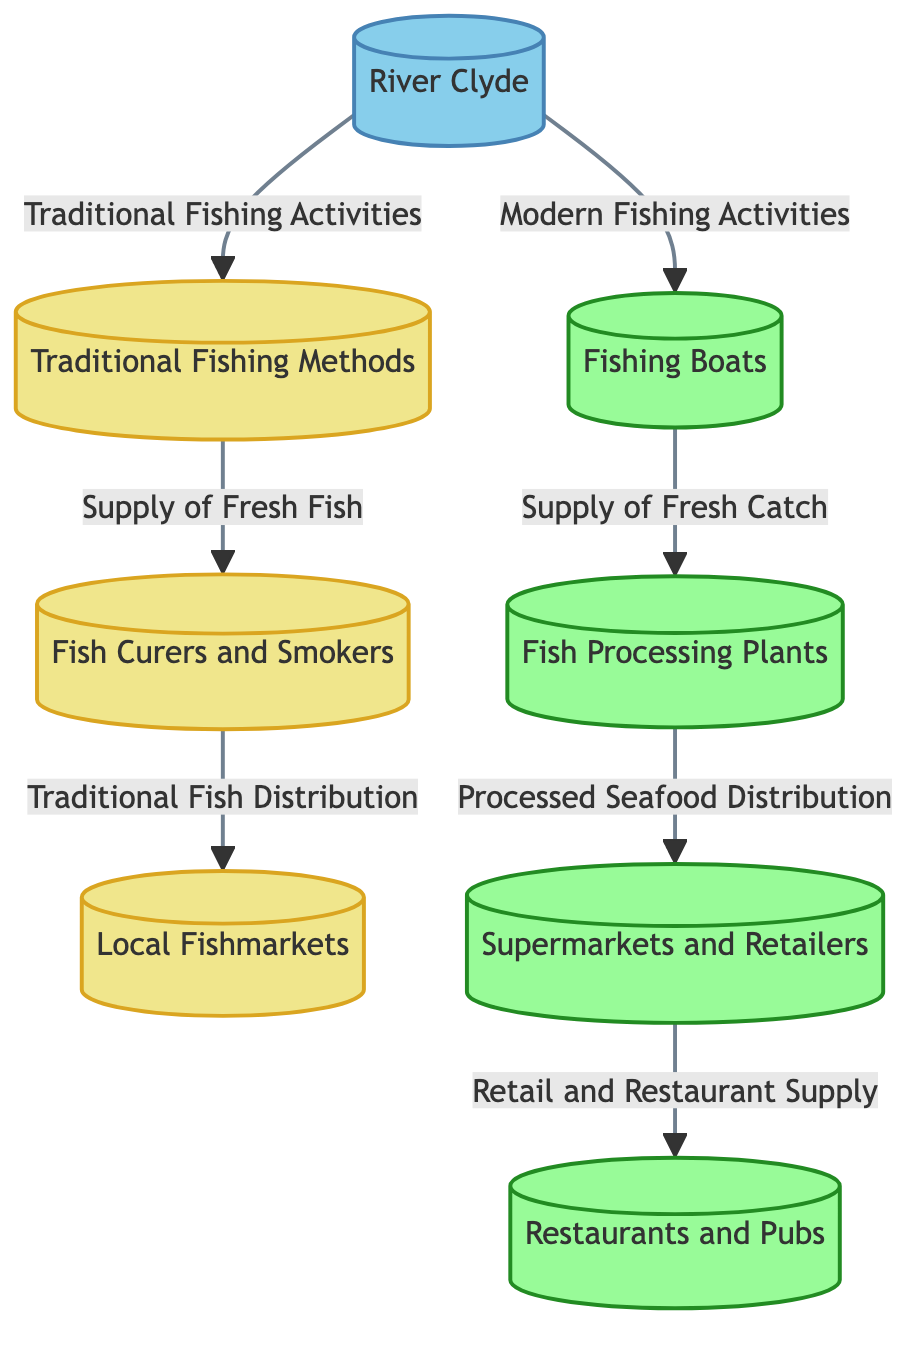How many nodes are there in the diagram? By counting all the individual components represented in the diagram, we identify 8 distinct nodes: River Clyde, Traditional Fishing Methods, Fish Curers and Smokers, Local Fishmarkets, Fishing Boats, Fish Processing Plants, Supermarkets and Retailers, and Restaurants and Pubs.
Answer: 8 What type of methods are represented by node "Traditional Fishing Methods"? The "Traditional Fishing Methods" node is classified in the diagram under the category of historical fishing practices, as indicated by the specific color coding for historical nodes.
Answer: historical Which node receives the supply of fresh fish from "Traditional Fishing Methods"? The diagram shows that the "Supply of Fresh Fish" from "Traditional Fishing Methods" flows to the "Fish Curers and Smokers" node, establishing the direct relationship between these two elements.
Answer: Fish Curers and Smokers What type of establishments are represented by "Supermarkets and Retailers"? "Supermarkets and Retailers" is classified in the diagram as a modern establishment since it uses the modern color definition provided in the coding logic.
Answer: modern What is the relationship between "Fishing Boats" and "Fish Processing Plants"? The relation illustrated in the diagram indicates that "Fishing Boats" provide the "Supply of Fresh Catch" which is directed towards "Fish Processing Plants," emphasizing a flow of products from boats to processing.
Answer: Supply of Fresh Catch How many traditional nodes are there in the diagram? The traditional nodes consist of "Traditional Fishing Methods," "Fish Curers and Smokers," and "Local Fishmarkets," which makes a total of 3 nodes categorized under traditional practices within the flowchart.
Answer: 3 Which node is the final destination for processed seafood distribution? According to the diagram, "Restaurants and Pubs" is the final destination as it receives the "Processed Seafood Distribution" from "Fish Processing Plants," demonstrating the flow of seafood to dining establishments.
Answer: Restaurants and Pubs What kind of fishing activities are associated with the "River Clyde"? The "River Clyde" in the diagram is directly connected to both "Traditional Fishing Activities" and "Modern Fishing Activities," indicating that it is the source for both historical and contemporary fishing practices in Govan.
Answer: Traditional Fishing Activities and Modern Fishing Activities What indicates the contemporary evolution in Govan fishing practices? The use of nodes such as "Fishing Boats," "Fish Processing Plants," "Supermarkets and Retailers," and "Restaurants and Pubs" signifies a shift towards modernized fishing practices and seafood distribution networks in Govan.
Answer: modernized fishing practices 